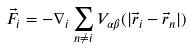Convert formula to latex. <formula><loc_0><loc_0><loc_500><loc_500>\vec { F } _ { i } = - \nabla _ { i } \sum _ { n \ne i } V _ { \alpha \beta } ( | \vec { r } _ { i } - \vec { r } _ { n } | )</formula> 